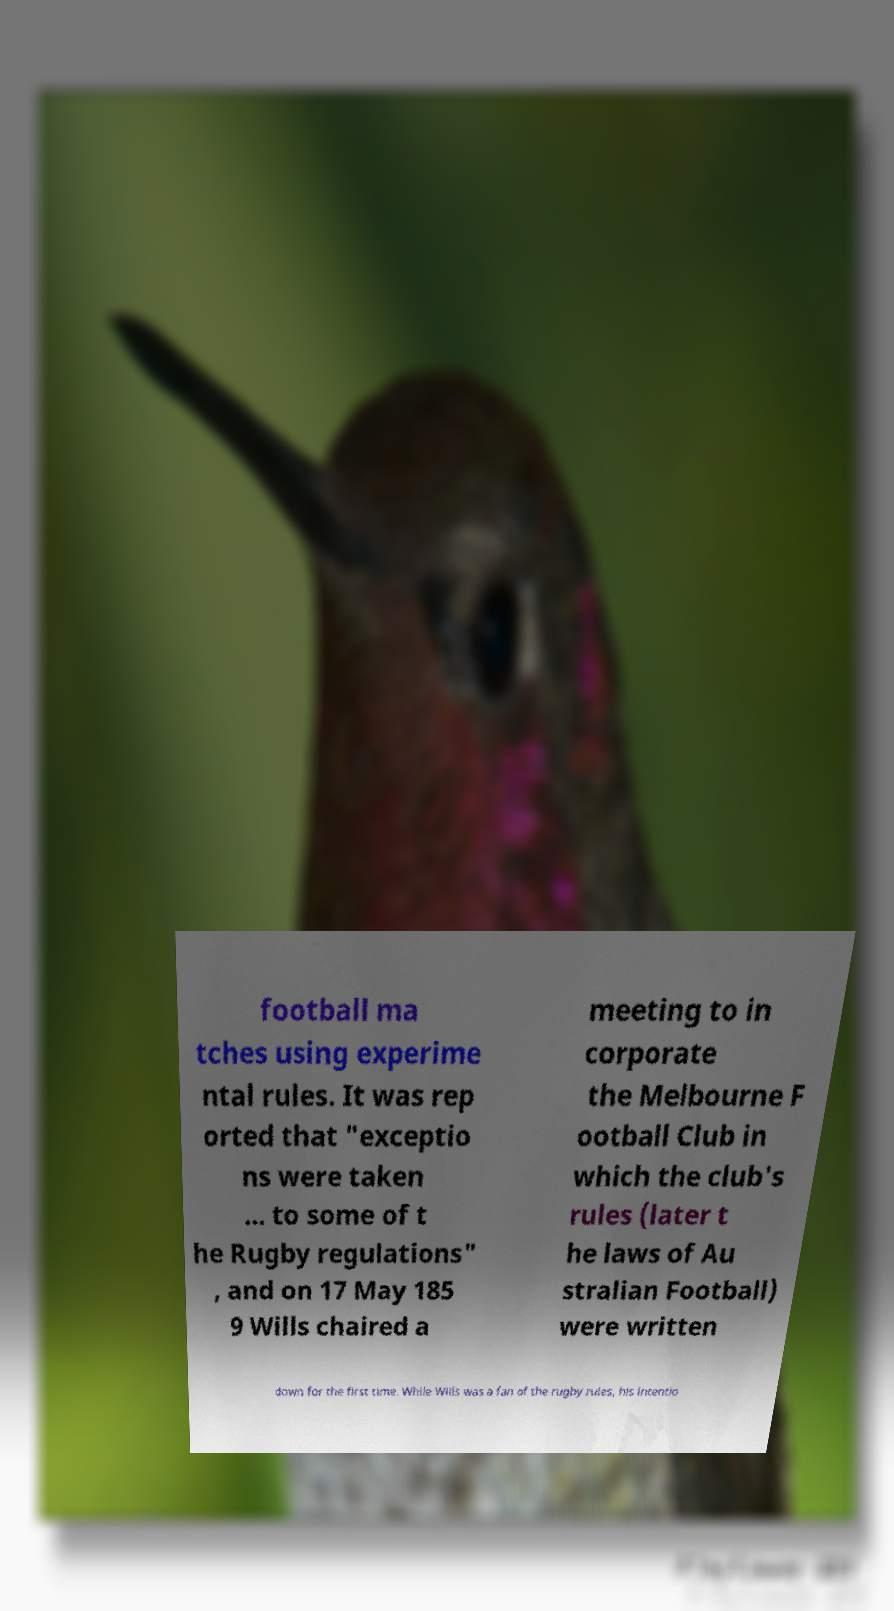Can you read and provide the text displayed in the image?This photo seems to have some interesting text. Can you extract and type it out for me? football ma tches using experime ntal rules. It was rep orted that "exceptio ns were taken … to some of t he Rugby regulations" , and on 17 May 185 9 Wills chaired a meeting to in corporate the Melbourne F ootball Club in which the club's rules (later t he laws of Au stralian Football) were written down for the first time. While Wills was a fan of the rugby rules, his intentio 